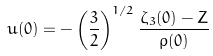<formula> <loc_0><loc_0><loc_500><loc_500>u ( 0 ) = - \left ( \frac { 3 } { 2 } \right ) ^ { 1 / 2 } \frac { \zeta _ { 3 } ( 0 ) - Z } { \rho ( 0 ) }</formula> 